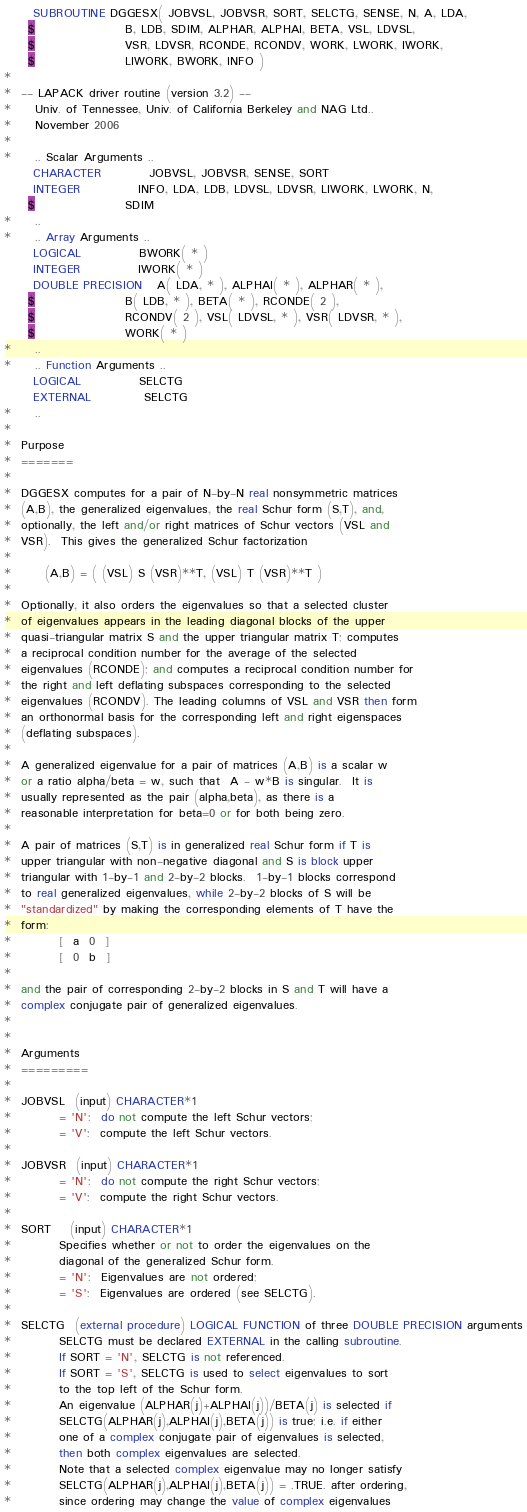<code> <loc_0><loc_0><loc_500><loc_500><_FORTRAN_>      SUBROUTINE DGGESX( JOBVSL, JOBVSR, SORT, SELCTG, SENSE, N, A, LDA,
     $                   B, LDB, SDIM, ALPHAR, ALPHAI, BETA, VSL, LDVSL,
     $                   VSR, LDVSR, RCONDE, RCONDV, WORK, LWORK, IWORK,
     $                   LIWORK, BWORK, INFO )
*
*  -- LAPACK driver routine (version 3.2) --
*     Univ. of Tennessee, Univ. of California Berkeley and NAG Ltd..
*     November 2006
*
*     .. Scalar Arguments ..
      CHARACTER          JOBVSL, JOBVSR, SENSE, SORT
      INTEGER            INFO, LDA, LDB, LDVSL, LDVSR, LIWORK, LWORK, N,
     $                   SDIM
*     ..
*     .. Array Arguments ..
      LOGICAL            BWORK( * )
      INTEGER            IWORK( * )
      DOUBLE PRECISION   A( LDA, * ), ALPHAI( * ), ALPHAR( * ),
     $                   B( LDB, * ), BETA( * ), RCONDE( 2 ),
     $                   RCONDV( 2 ), VSL( LDVSL, * ), VSR( LDVSR, * ),
     $                   WORK( * )
*     ..
*     .. Function Arguments ..
      LOGICAL            SELCTG
      EXTERNAL           SELCTG
*     ..
*
*  Purpose
*  =======
*
*  DGGESX computes for a pair of N-by-N real nonsymmetric matrices
*  (A,B), the generalized eigenvalues, the real Schur form (S,T), and,
*  optionally, the left and/or right matrices of Schur vectors (VSL and
*  VSR).  This gives the generalized Schur factorization
*
*       (A,B) = ( (VSL) S (VSR)**T, (VSL) T (VSR)**T )
*
*  Optionally, it also orders the eigenvalues so that a selected cluster
*  of eigenvalues appears in the leading diagonal blocks of the upper
*  quasi-triangular matrix S and the upper triangular matrix T; computes
*  a reciprocal condition number for the average of the selected
*  eigenvalues (RCONDE); and computes a reciprocal condition number for
*  the right and left deflating subspaces corresponding to the selected
*  eigenvalues (RCONDV). The leading columns of VSL and VSR then form
*  an orthonormal basis for the corresponding left and right eigenspaces
*  (deflating subspaces).
*
*  A generalized eigenvalue for a pair of matrices (A,B) is a scalar w
*  or a ratio alpha/beta = w, such that  A - w*B is singular.  It is
*  usually represented as the pair (alpha,beta), as there is a
*  reasonable interpretation for beta=0 or for both being zero.
*
*  A pair of matrices (S,T) is in generalized real Schur form if T is
*  upper triangular with non-negative diagonal and S is block upper
*  triangular with 1-by-1 and 2-by-2 blocks.  1-by-1 blocks correspond
*  to real generalized eigenvalues, while 2-by-2 blocks of S will be
*  "standardized" by making the corresponding elements of T have the
*  form:
*          [  a  0  ]
*          [  0  b  ]
*
*  and the pair of corresponding 2-by-2 blocks in S and T will have a
*  complex conjugate pair of generalized eigenvalues.
*
*
*  Arguments
*  =========
*
*  JOBVSL  (input) CHARACTER*1
*          = 'N':  do not compute the left Schur vectors;
*          = 'V':  compute the left Schur vectors.
*
*  JOBVSR  (input) CHARACTER*1
*          = 'N':  do not compute the right Schur vectors;
*          = 'V':  compute the right Schur vectors.
*
*  SORT    (input) CHARACTER*1
*          Specifies whether or not to order the eigenvalues on the
*          diagonal of the generalized Schur form.
*          = 'N':  Eigenvalues are not ordered;
*          = 'S':  Eigenvalues are ordered (see SELCTG).
*
*  SELCTG  (external procedure) LOGICAL FUNCTION of three DOUBLE PRECISION arguments
*          SELCTG must be declared EXTERNAL in the calling subroutine.
*          If SORT = 'N', SELCTG is not referenced.
*          If SORT = 'S', SELCTG is used to select eigenvalues to sort
*          to the top left of the Schur form.
*          An eigenvalue (ALPHAR(j)+ALPHAI(j))/BETA(j) is selected if
*          SELCTG(ALPHAR(j),ALPHAI(j),BETA(j)) is true; i.e. if either
*          one of a complex conjugate pair of eigenvalues is selected,
*          then both complex eigenvalues are selected.
*          Note that a selected complex eigenvalue may no longer satisfy
*          SELCTG(ALPHAR(j),ALPHAI(j),BETA(j)) = .TRUE. after ordering,
*          since ordering may change the value of complex eigenvalues</code> 